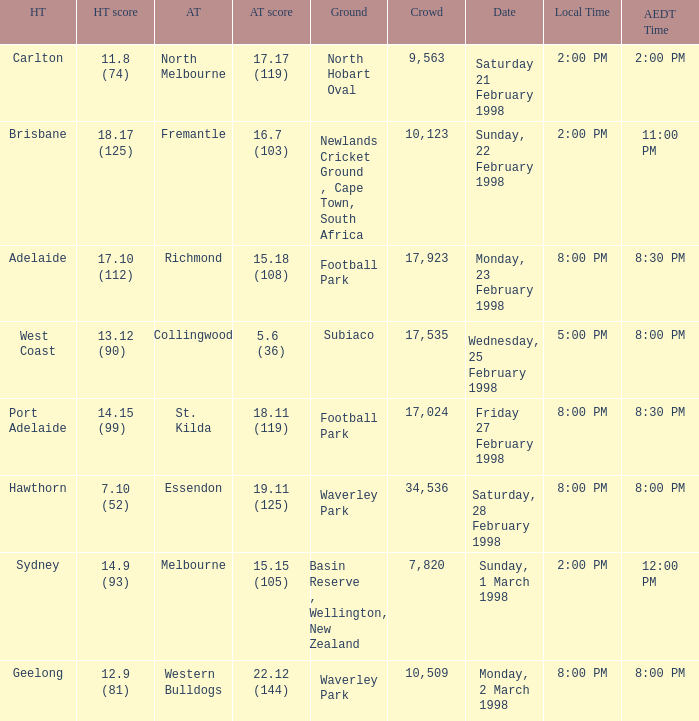Which Home team is on Wednesday, 25 february 1998? West Coast. 